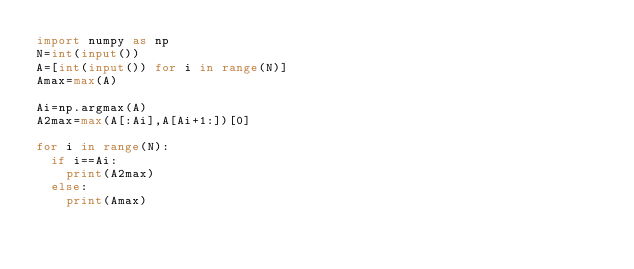<code> <loc_0><loc_0><loc_500><loc_500><_Python_>import numpy as np
N=int(input())
A=[int(input()) for i in range(N)]
Amax=max(A)

Ai=np.argmax(A)
A2max=max(A[:Ai],A[Ai+1:])[0]

for i in range(N):
  if i==Ai:
    print(A2max)
  else:
    print(Amax)</code> 